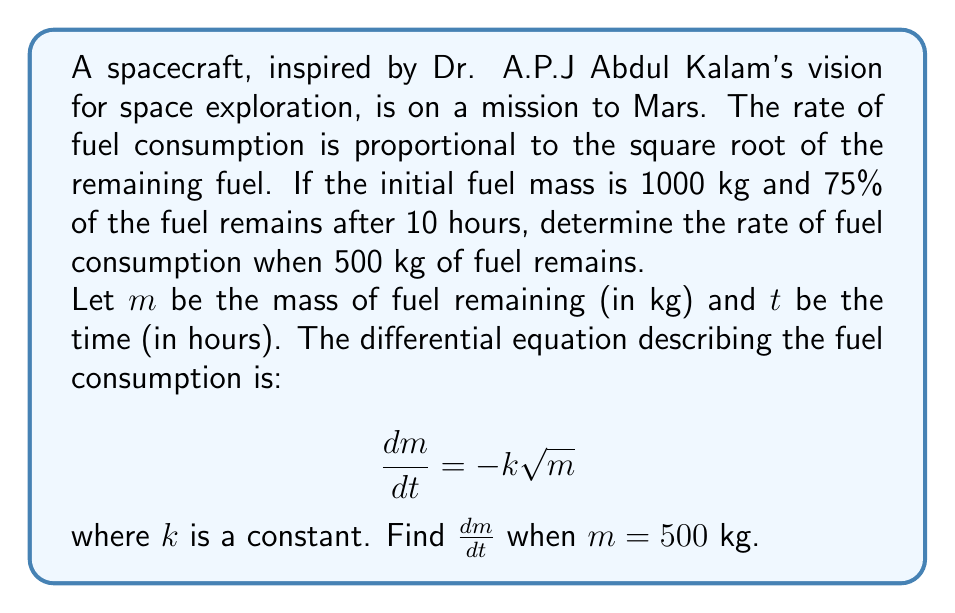Help me with this question. Let's solve this problem step by step:

1) We're given that $\frac{dm}{dt} = -k\sqrt{m}$. We need to find $k$ first.

2) To solve for $k$, we can use the given information:
   Initial fuel mass $m_0 = 1000$ kg
   After 10 hours, 75% remains, so $m(10) = 750$ kg

3) Separating variables and integrating:

   $$\int_{1000}^{750} \frac{dm}{\sqrt{m}} = -k \int_0^{10} dt$$

4) Solving the integrals:

   $$2(\sqrt{750} - \sqrt{1000}) = -10k$$

5) Simplifying:

   $$2(27.39 - 31.62) = -10k$$
   $$-8.46 = -10k$$
   $$k = 0.846$$

6) Now that we have $k$, we can find $\frac{dm}{dt}$ when $m = 500$ kg:

   $$\frac{dm}{dt} = -0.846\sqrt{500}$$

7) Calculating the final result:

   $$\frac{dm}{dt} = -0.846 \cdot 22.36 = -18.92$$
Answer: The rate of fuel consumption when 500 kg of fuel remains is approximately $-18.92$ kg/hour. 